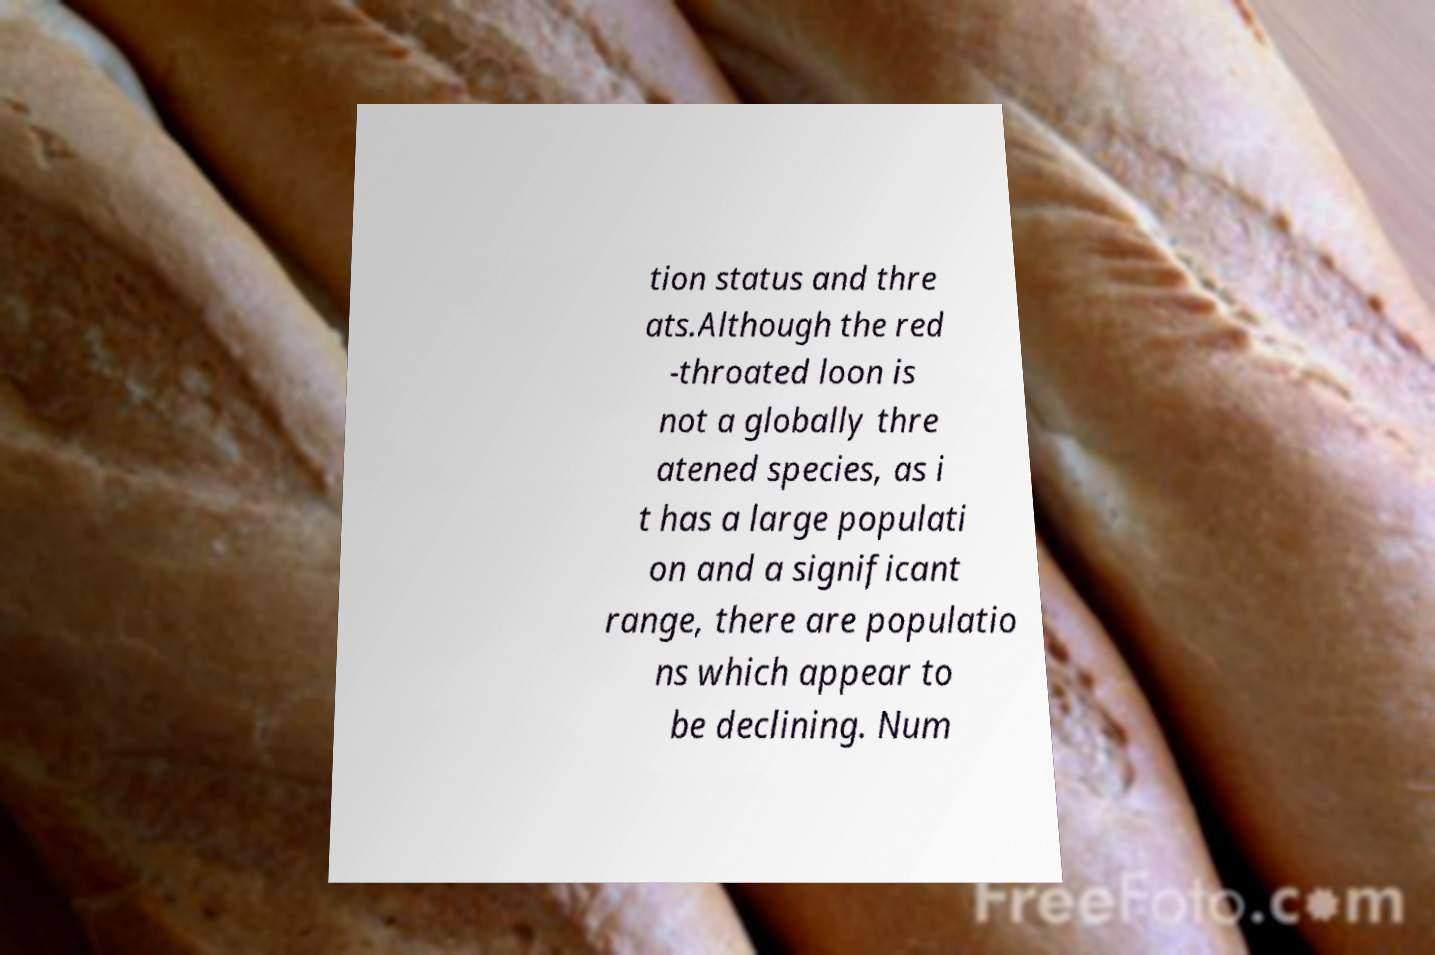I need the written content from this picture converted into text. Can you do that? tion status and thre ats.Although the red -throated loon is not a globally thre atened species, as i t has a large populati on and a significant range, there are populatio ns which appear to be declining. Num 